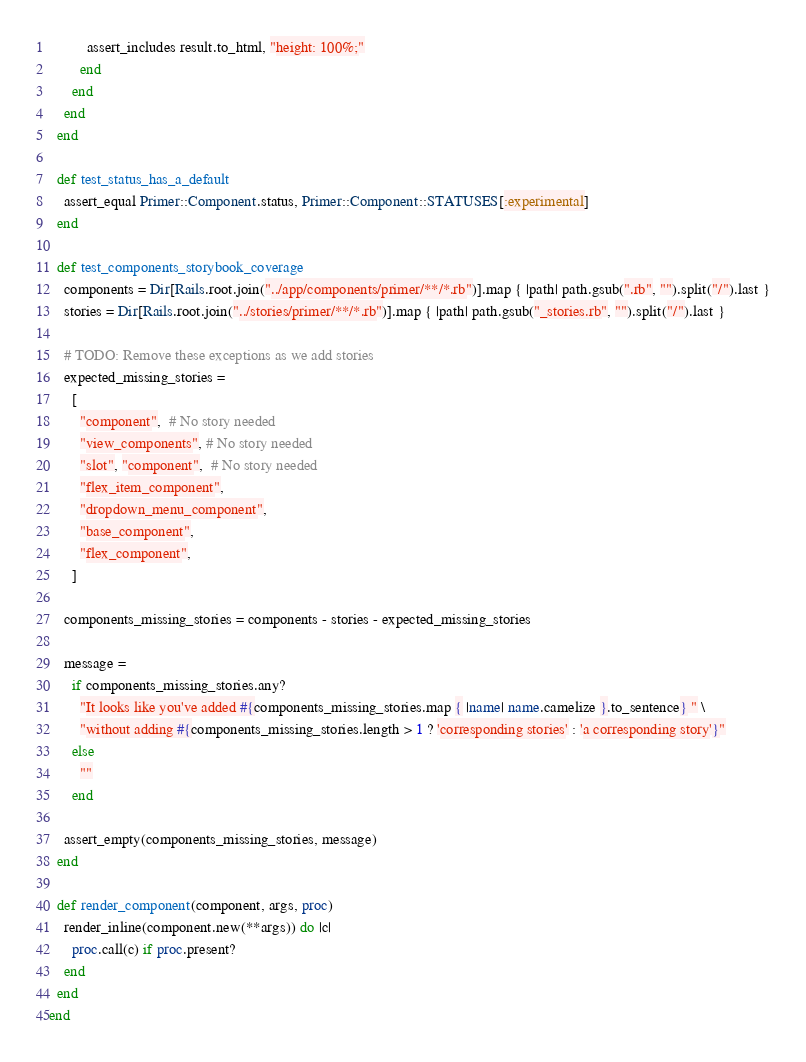Convert code to text. <code><loc_0><loc_0><loc_500><loc_500><_Ruby_>          assert_includes result.to_html, "height: 100%;"
        end
      end
    end
  end

  def test_status_has_a_default
    assert_equal Primer::Component.status, Primer::Component::STATUSES[:experimental]
  end

  def test_components_storybook_coverage
    components = Dir[Rails.root.join("../app/components/primer/**/*.rb")].map { |path| path.gsub(".rb", "").split("/").last }
    stories = Dir[Rails.root.join("../stories/primer/**/*.rb")].map { |path| path.gsub("_stories.rb", "").split("/").last }

    # TODO: Remove these exceptions as we add stories
    expected_missing_stories =
      [
        "component",  # No story needed
        "view_components", # No story needed
        "slot", "component",  # No story needed
        "flex_item_component",
        "dropdown_menu_component",
        "base_component",
        "flex_component",
      ]

    components_missing_stories = components - stories - expected_missing_stories

    message =
      if components_missing_stories.any?
        "It looks like you've added #{components_missing_stories.map { |name| name.camelize }.to_sentence} " \
        "without adding #{components_missing_stories.length > 1 ? 'corresponding stories' : 'a corresponding story'}"
      else
        ""
      end

    assert_empty(components_missing_stories, message)
  end

  def render_component(component, args, proc)
    render_inline(component.new(**args)) do |c|
      proc.call(c) if proc.present?
    end
  end
end
</code> 